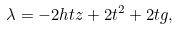Convert formula to latex. <formula><loc_0><loc_0><loc_500><loc_500>\lambda = - 2 h t z + 2 t ^ { 2 } + 2 t g ,</formula> 